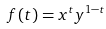Convert formula to latex. <formula><loc_0><loc_0><loc_500><loc_500>f ( t ) = x ^ { t } y ^ { 1 - t }</formula> 